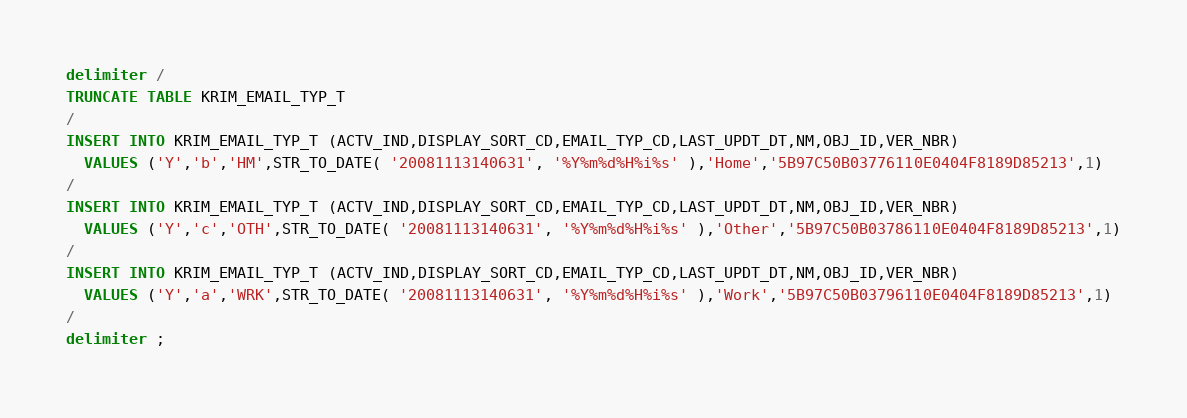<code> <loc_0><loc_0><loc_500><loc_500><_SQL_>delimiter /
TRUNCATE TABLE KRIM_EMAIL_TYP_T
/
INSERT INTO KRIM_EMAIL_TYP_T (ACTV_IND,DISPLAY_SORT_CD,EMAIL_TYP_CD,LAST_UPDT_DT,NM,OBJ_ID,VER_NBR)
  VALUES ('Y','b','HM',STR_TO_DATE( '20081113140631', '%Y%m%d%H%i%s' ),'Home','5B97C50B03776110E0404F8189D85213',1)
/
INSERT INTO KRIM_EMAIL_TYP_T (ACTV_IND,DISPLAY_SORT_CD,EMAIL_TYP_CD,LAST_UPDT_DT,NM,OBJ_ID,VER_NBR)
  VALUES ('Y','c','OTH',STR_TO_DATE( '20081113140631', '%Y%m%d%H%i%s' ),'Other','5B97C50B03786110E0404F8189D85213',1)
/
INSERT INTO KRIM_EMAIL_TYP_T (ACTV_IND,DISPLAY_SORT_CD,EMAIL_TYP_CD,LAST_UPDT_DT,NM,OBJ_ID,VER_NBR)
  VALUES ('Y','a','WRK',STR_TO_DATE( '20081113140631', '%Y%m%d%H%i%s' ),'Work','5B97C50B03796110E0404F8189D85213',1)
/
delimiter ;
</code> 